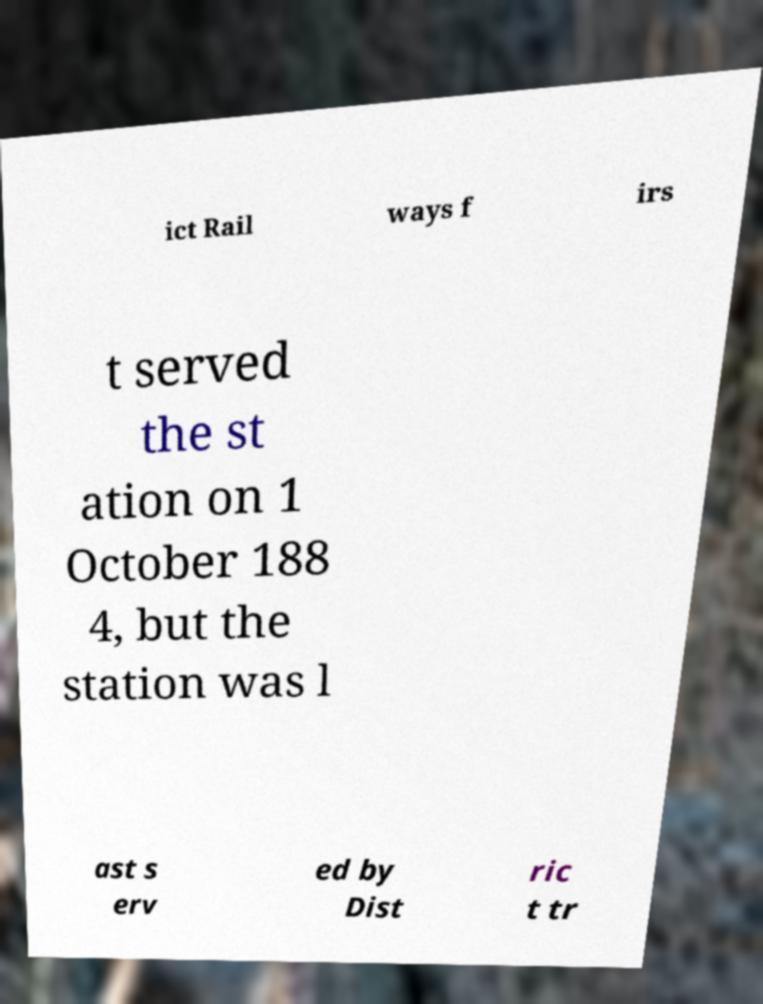Please read and relay the text visible in this image. What does it say? ict Rail ways f irs t served the st ation on 1 October 188 4, but the station was l ast s erv ed by Dist ric t tr 